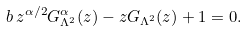Convert formula to latex. <formula><loc_0><loc_0><loc_500><loc_500>b \, z ^ { \alpha / 2 } G _ { \Lambda ^ { 2 } } ^ { \alpha } ( z ) - z G _ { \Lambda ^ { 2 } } ( z ) + 1 = 0 .</formula> 